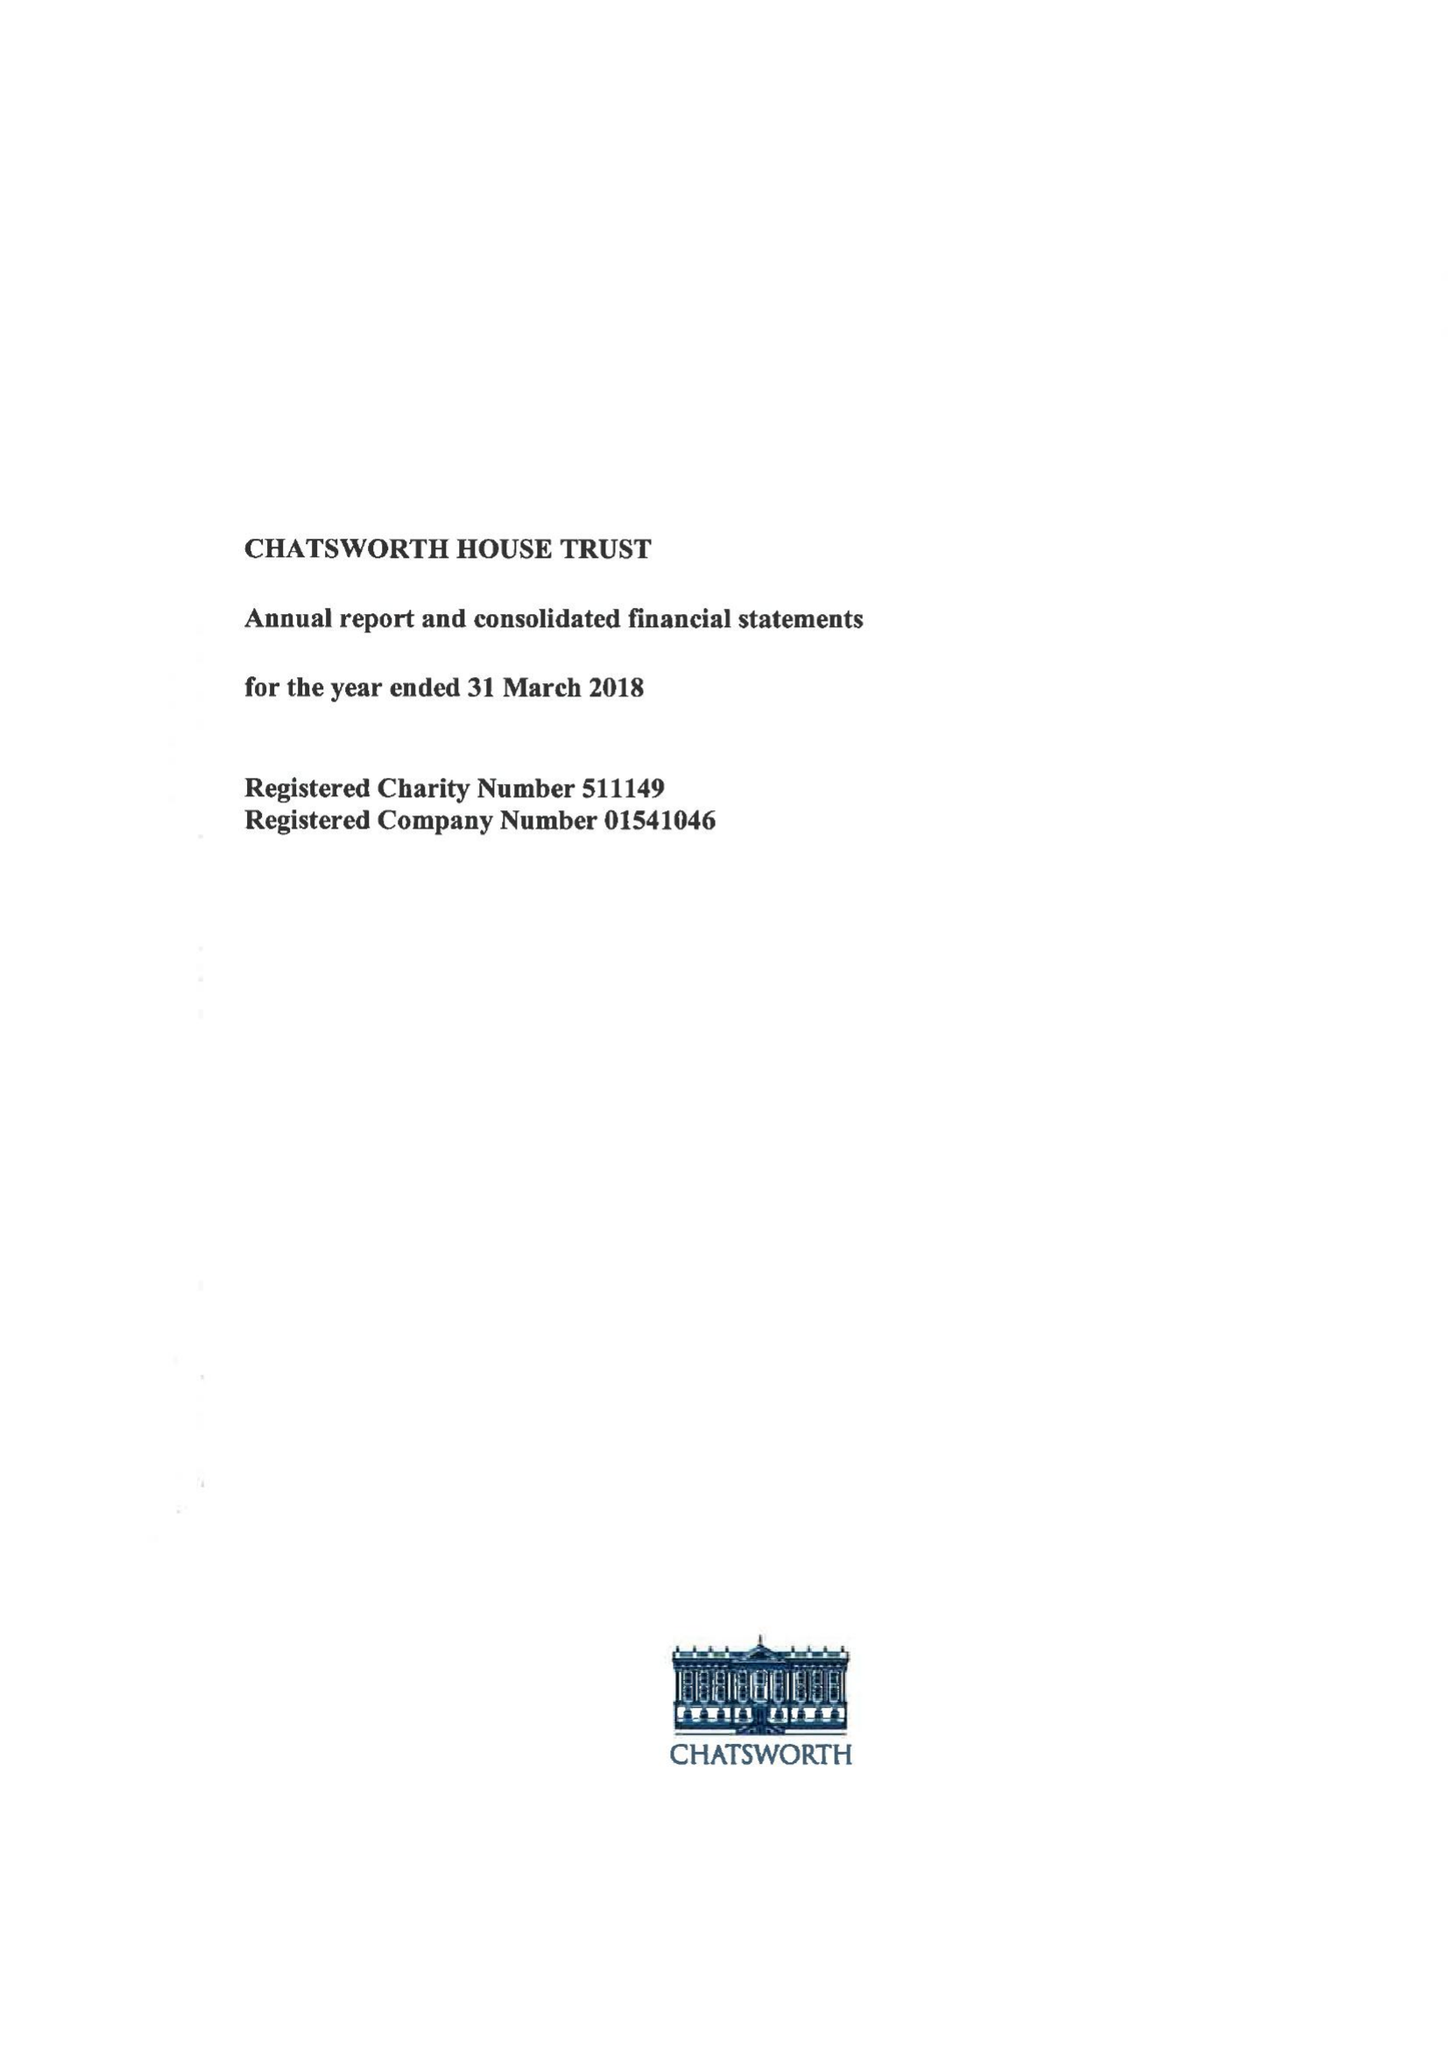What is the value for the report_date?
Answer the question using a single word or phrase. 2018-03-31 